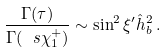Convert formula to latex. <formula><loc_0><loc_0><loc_500><loc_500>\frac { \Gamma ( \tau ) } { \Gamma ( \ s \chi _ { 1 } ^ { + } ) } \sim \sin ^ { 2 } \xi ^ { \prime } \hat { h } _ { b } ^ { 2 } \, .</formula> 